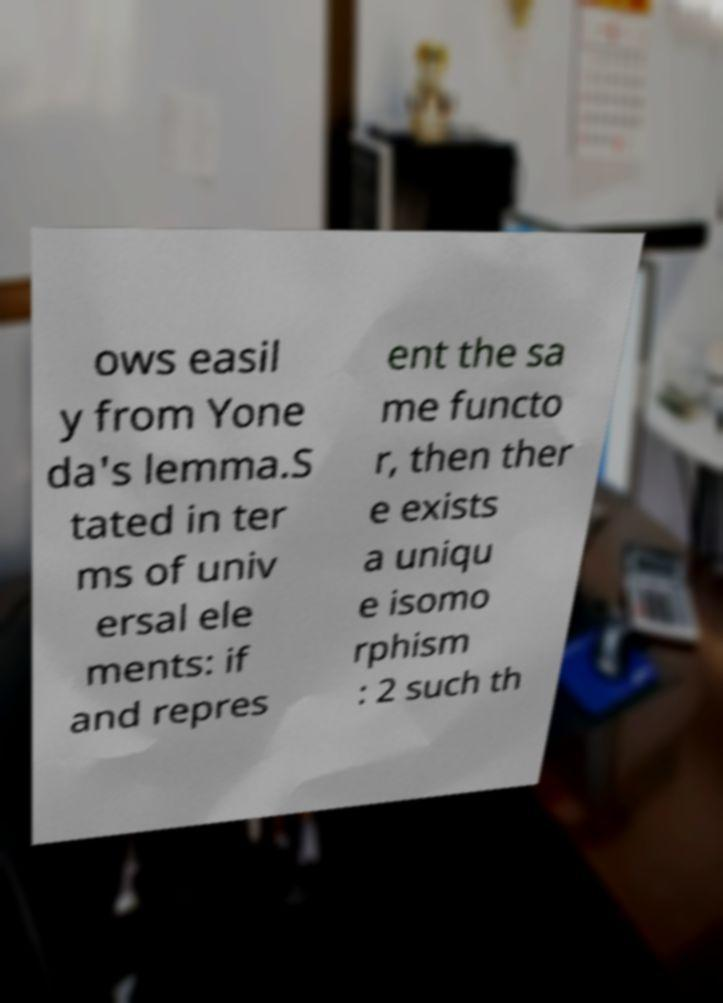I need the written content from this picture converted into text. Can you do that? ows easil y from Yone da's lemma.S tated in ter ms of univ ersal ele ments: if and repres ent the sa me functo r, then ther e exists a uniqu e isomo rphism : 2 such th 